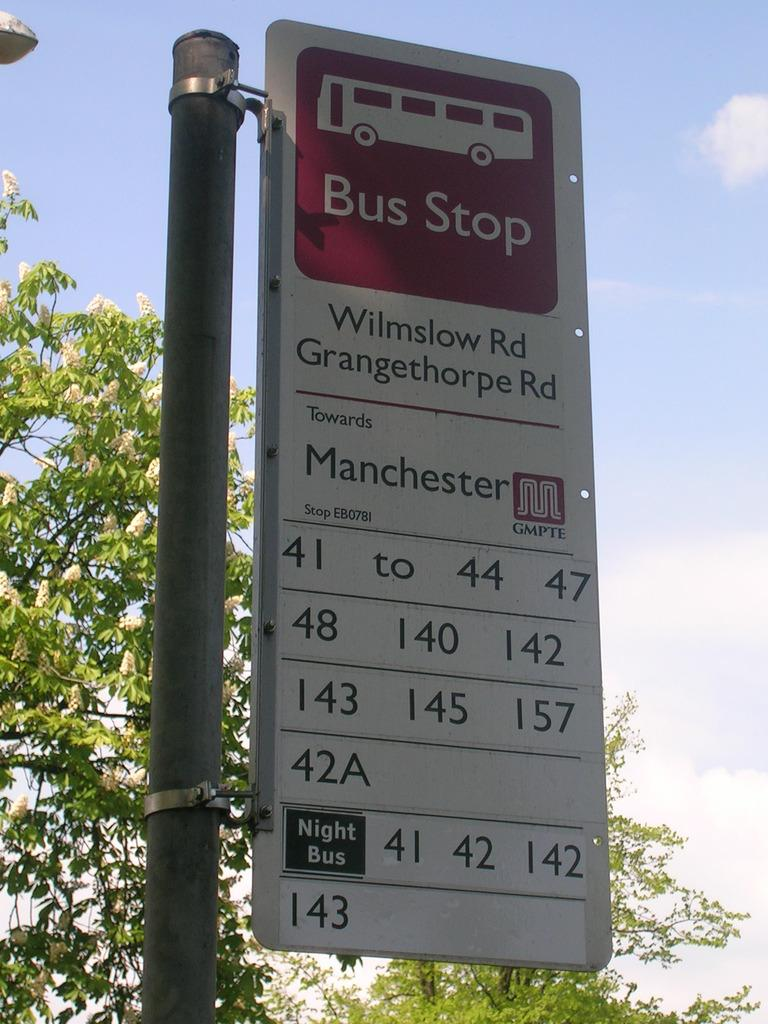What is present at the bus stop in the image? There is a hoarding at the bus stop in the image. What can be seen behind the hoarding? There is a tree visible behind the hoarding. What type of iron is being used to treat the disease in the image? There is no iron or disease present in the image; it features a hoarding at a bus stop with a tree behind it. 